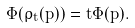<formula> <loc_0><loc_0><loc_500><loc_500>\Phi ( \rho _ { t } ( p ) ) = t \Phi ( p ) .</formula> 